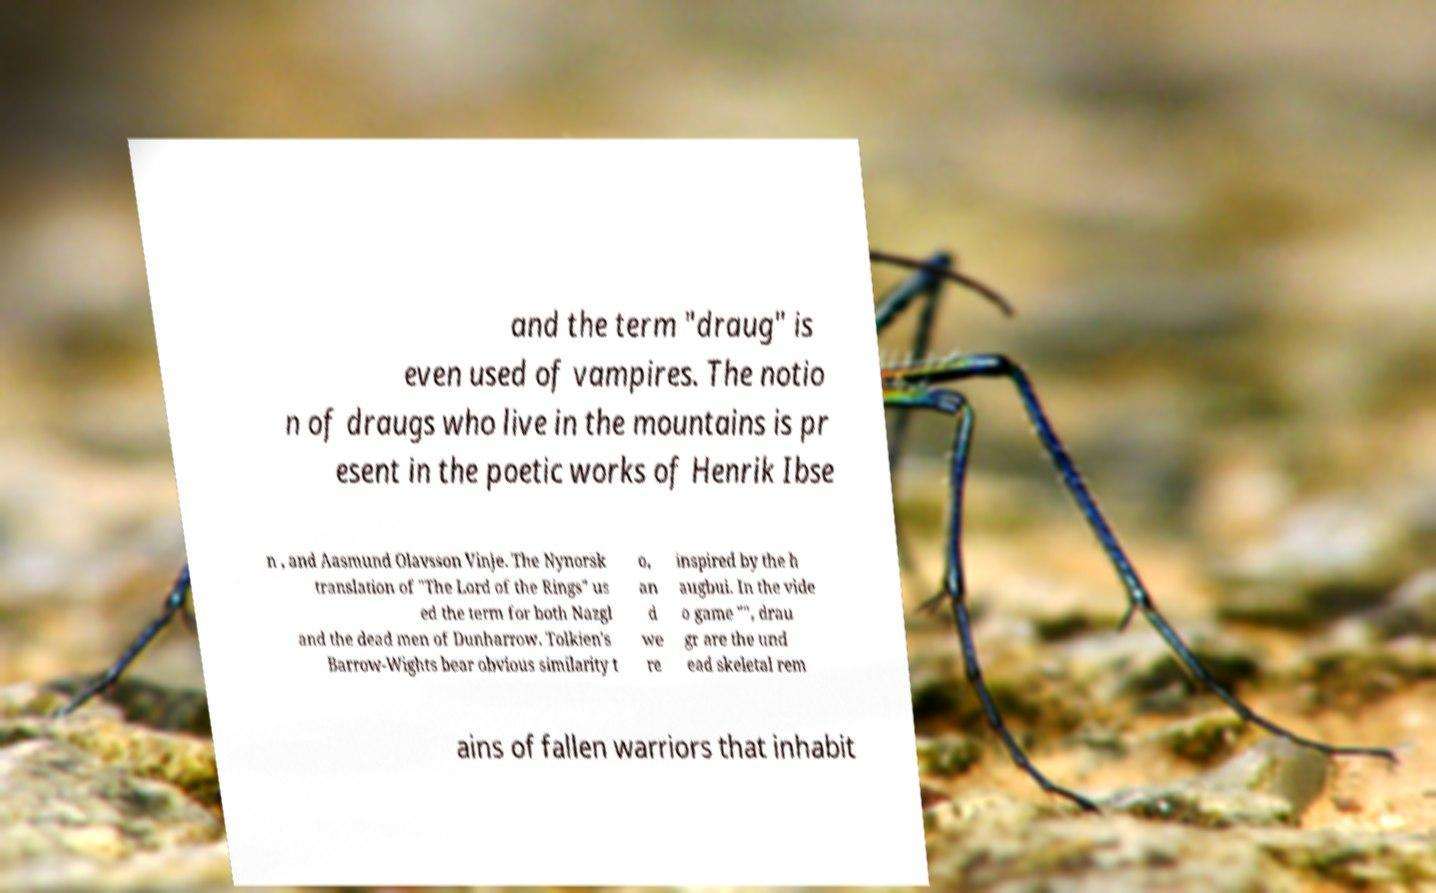Can you read and provide the text displayed in the image?This photo seems to have some interesting text. Can you extract and type it out for me? and the term "draug" is even used of vampires. The notio n of draugs who live in the mountains is pr esent in the poetic works of Henrik Ibse n , and Aasmund Olavsson Vinje. The Nynorsk translation of "The Lord of the Rings" us ed the term for both Nazgl and the dead men of Dunharrow. Tolkien's Barrow-Wights bear obvious similarity t o, an d we re inspired by the h augbui. In the vide o game "", drau gr are the und ead skeletal rem ains of fallen warriors that inhabit 